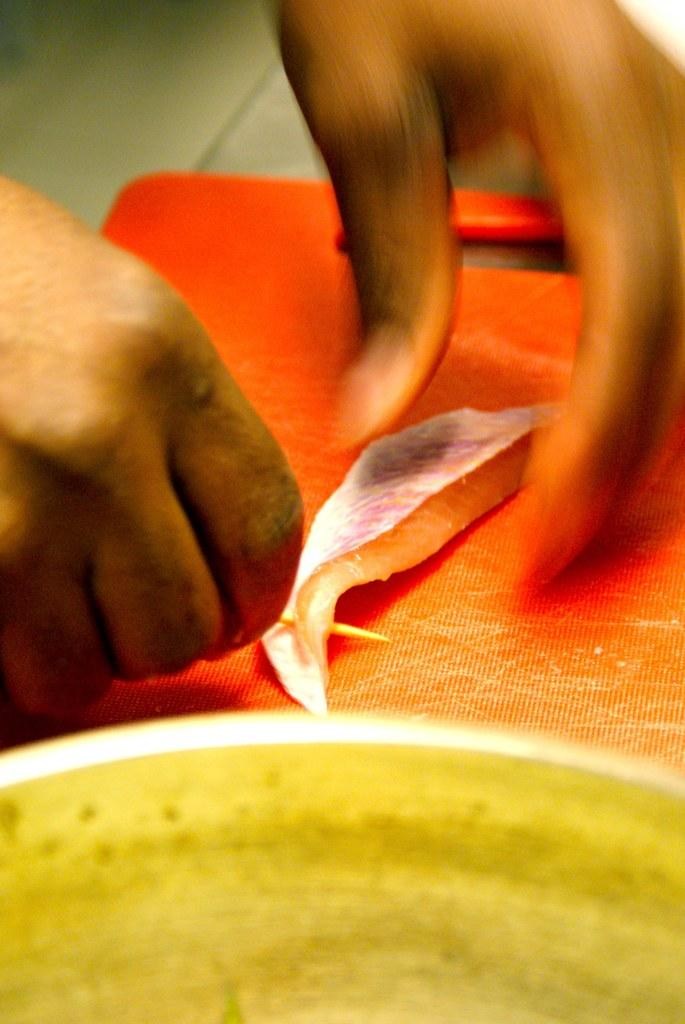What is present on the table in the image? There is a chopping board on the table in the image. What is on top of the chopping board? There is a fish on the chopping board. Who is in the image? There is a man in the image. What is the man doing with the fish? The man is holding the fish. What type of veil is draped over the fish in the image? There is no veil present in the image; the fish is simply on the chopping board. 